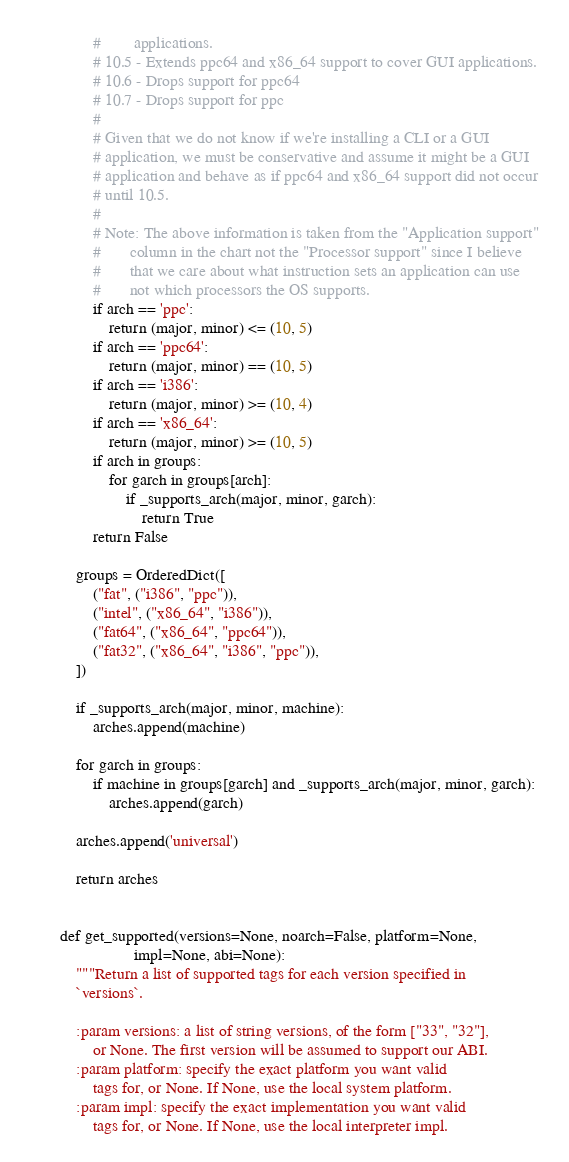<code> <loc_0><loc_0><loc_500><loc_500><_Python_>        #        applications.
        # 10.5 - Extends ppc64 and x86_64 support to cover GUI applications.
        # 10.6 - Drops support for ppc64
        # 10.7 - Drops support for ppc
        #
        # Given that we do not know if we're installing a CLI or a GUI
        # application, we must be conservative and assume it might be a GUI
        # application and behave as if ppc64 and x86_64 support did not occur
        # until 10.5.
        #
        # Note: The above information is taken from the "Application support"
        #       column in the chart not the "Processor support" since I believe
        #       that we care about what instruction sets an application can use
        #       not which processors the OS supports.
        if arch == 'ppc':
            return (major, minor) <= (10, 5)
        if arch == 'ppc64':
            return (major, minor) == (10, 5)
        if arch == 'i386':
            return (major, minor) >= (10, 4)
        if arch == 'x86_64':
            return (major, minor) >= (10, 5)
        if arch in groups:
            for garch in groups[arch]:
                if _supports_arch(major, minor, garch):
                    return True
        return False

    groups = OrderedDict([
        ("fat", ("i386", "ppc")),
        ("intel", ("x86_64", "i386")),
        ("fat64", ("x86_64", "ppc64")),
        ("fat32", ("x86_64", "i386", "ppc")),
    ])

    if _supports_arch(major, minor, machine):
        arches.append(machine)

    for garch in groups:
        if machine in groups[garch] and _supports_arch(major, minor, garch):
            arches.append(garch)

    arches.append('universal')

    return arches


def get_supported(versions=None, noarch=False, platform=None,
                  impl=None, abi=None):
    """Return a list of supported tags for each version specified in
    `versions`.

    :param versions: a list of string versions, of the form ["33", "32"],
        or None. The first version will be assumed to support our ABI.
    :param platform: specify the exact platform you want valid
        tags for, or None. If None, use the local system platform.
    :param impl: specify the exact implementation you want valid
        tags for, or None. If None, use the local interpreter impl.</code> 